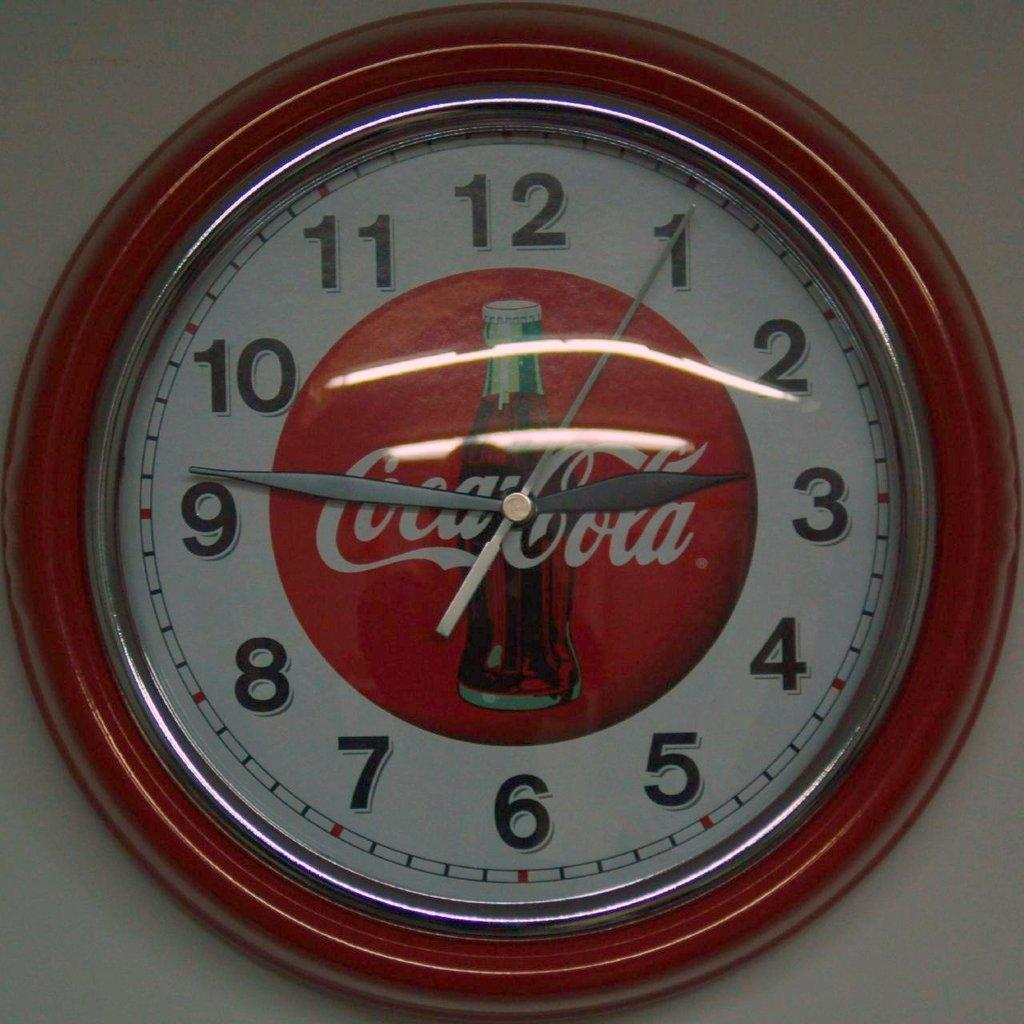Provide a one-sentence caption for the provided image. A wall clock with a Coca-Cola logo showing a time of 9:14. 